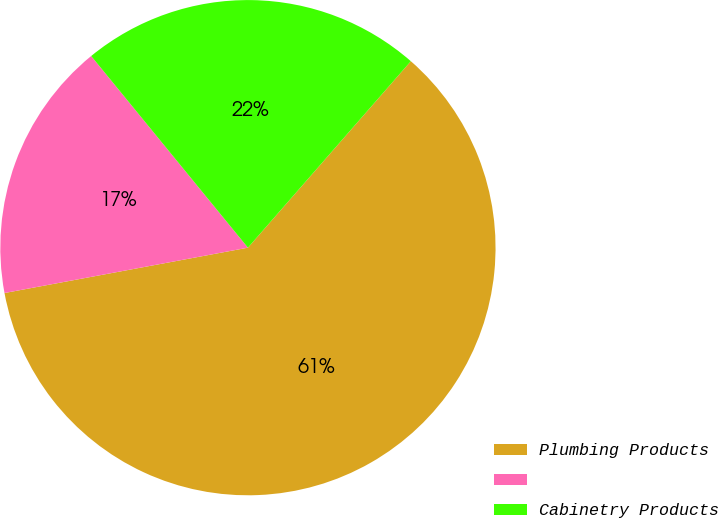<chart> <loc_0><loc_0><loc_500><loc_500><pie_chart><fcel>Plumbing Products<fcel>Unnamed: 1<fcel>Cabinetry Products<nl><fcel>60.64%<fcel>17.02%<fcel>22.34%<nl></chart> 